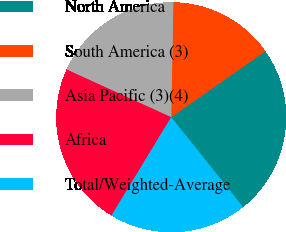<chart> <loc_0><loc_0><loc_500><loc_500><pie_chart><fcel>North America<fcel>South America (3)<fcel>Asia Pacific (3)(4)<fcel>Africa<fcel>Total/Weighted-Average<nl><fcel>23.99%<fcel>14.98%<fcel>18.49%<fcel>23.12%<fcel>19.42%<nl></chart> 